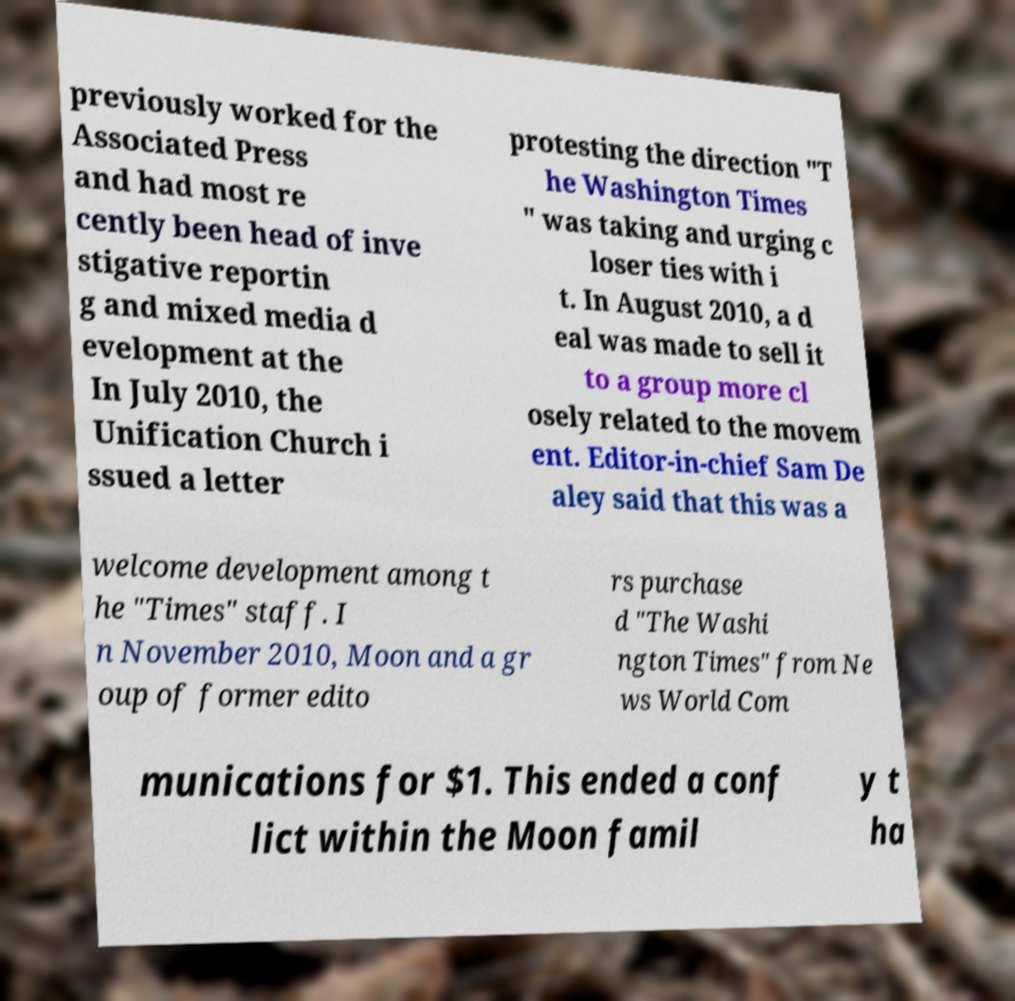Can you accurately transcribe the text from the provided image for me? previously worked for the Associated Press and had most re cently been head of inve stigative reportin g and mixed media d evelopment at the In July 2010, the Unification Church i ssued a letter protesting the direction "T he Washington Times " was taking and urging c loser ties with i t. In August 2010, a d eal was made to sell it to a group more cl osely related to the movem ent. Editor-in-chief Sam De aley said that this was a welcome development among t he "Times" staff. I n November 2010, Moon and a gr oup of former edito rs purchase d "The Washi ngton Times" from Ne ws World Com munications for $1. This ended a conf lict within the Moon famil y t ha 